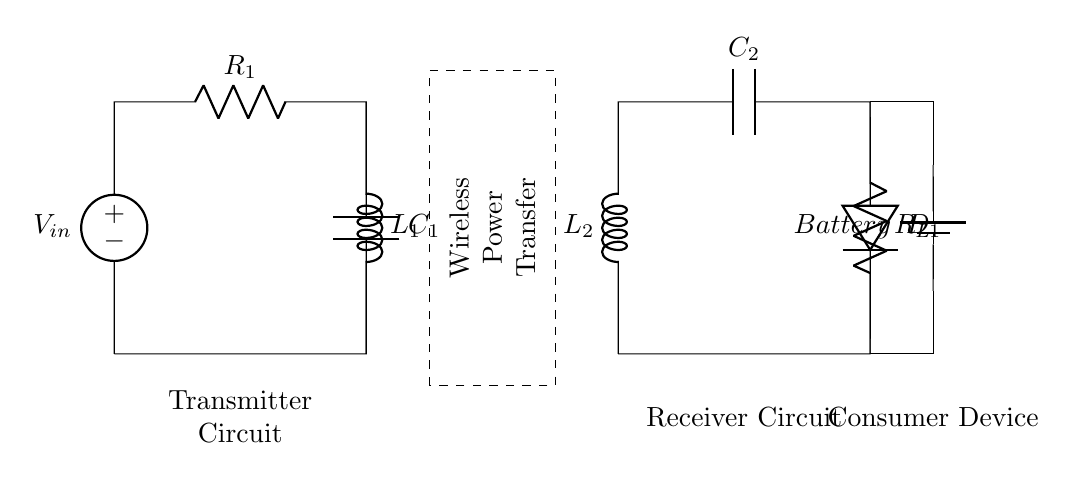What type of circuit is this? This circuit represents a wireless power transfer system aimed at charging consumer electronics. It includes a transmitter and receiver circuit, with a focus on the inductive coupling method for transferring energy wirelessly.
Answer: Wireless power transfer What is the role of L1 in the circuit? L1 is an inductor located in the transmitter side. Its primary role is to store energy in the magnetic field when current flows through it, enabling the wireless power transfer to the receiver.
Answer: Energy storage How many capacitors are in the circuit? The circuit diagram includes two capacitors: C1 on the transmitter side and C2 on the receiver side. Each capacitor serves to filter and stabilize the voltage in their respective circuits.
Answer: Two What component is responsible for rectification in the circuit? The diode D1, situated in the receiver circuit, is responsible for rectifying the alternating current received from the wireless power transfer, converting it to direct current suitable for charging the battery.
Answer: Diode What is the function of the battery in this circuit? The battery serves to store the electrical energy that has been wirelessly transferred and rectified by the circuit. It is essential for powering consumer devices after the charging process.
Answer: Energy storage How are the transmitter and receiver circuits connected? The transmitter circuit's output connects wirelessly (indicated by dashed lines) to the receiver circuit, which enables it to transfer power without physical connections. This is a key feature of wireless charging technology.
Answer: Wirelessly What does R_L represent in the receiver circuit? R_L represents the load resistor that the battery must charge; it represents the resistance that the load (in this case, a consumer device) presents to the circuit when power is being used from the battery.
Answer: Load resistor 